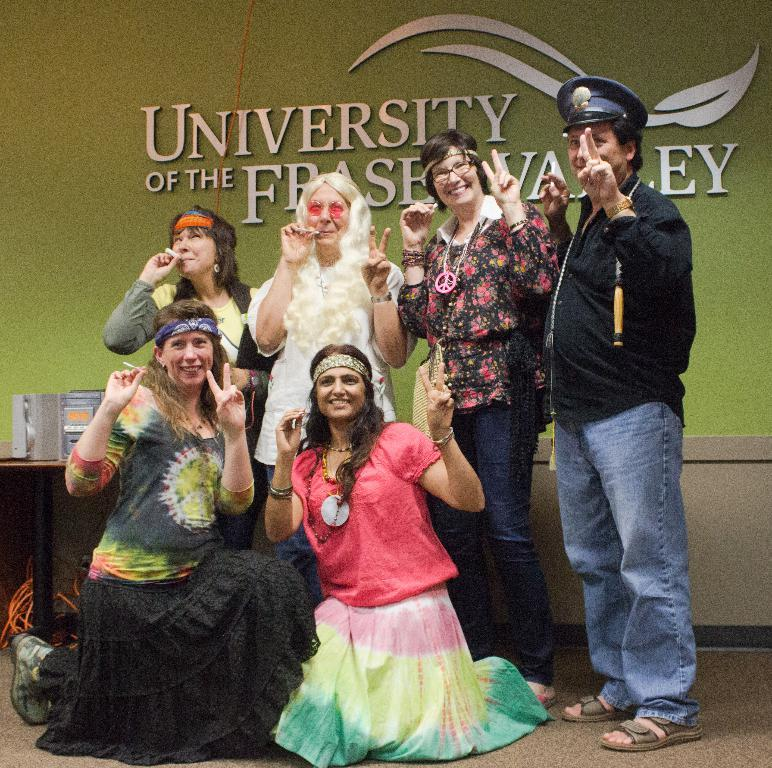How many people are in the image? There is a group of people in the image. What is the facial expression of the people in the image? The people are smiling. What else can be seen in the image besides the people? There are cables visible in the image. What is on the table in the image? There are objects on a table in the image. How many bags are being carried by the people in the image? There is no mention of bags in the image; the people are not carrying any visible bags. Are there any bikes in the image? There is no mention of bikes in the image; they are not present. 